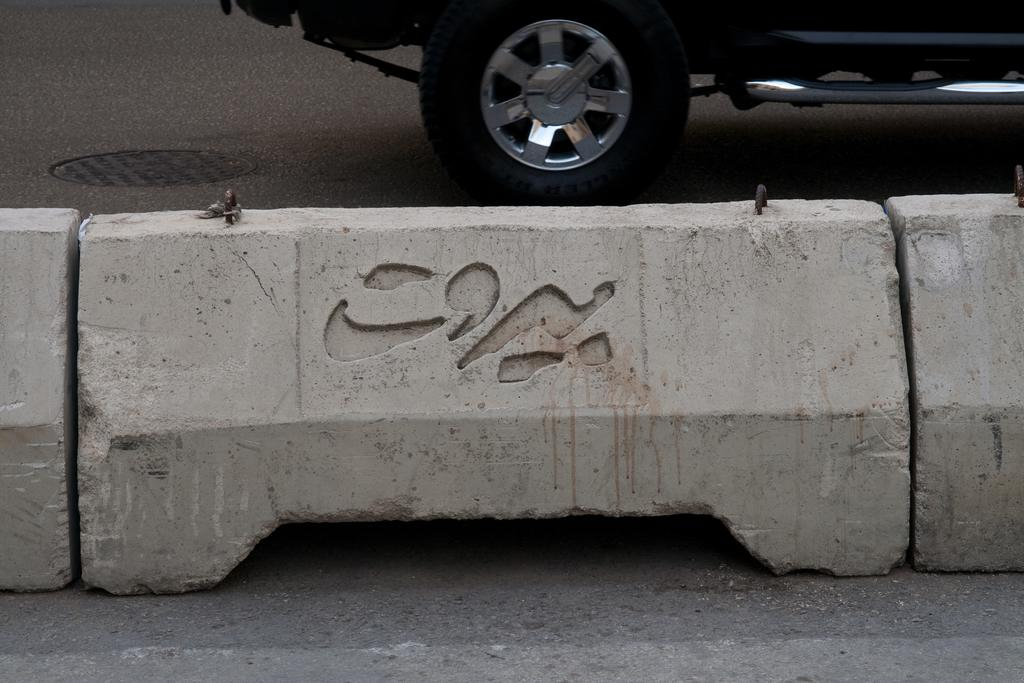What is the main feature of the image? There is a road in the image. Are there any distinguishing features on the road? Yes, there is a divider on the road. What color is the divider? The divider is ash in color. What type of vehicle can be seen on the road? There is a black vehicle on the road. How many members are on the team that is playing on the bridge in the image? There is no team or bridge present in the image; it features a road with a divider and a black vehicle. What type of mint is growing on the side of the road in the image? There is no mint plant visible in the image; it only shows a road, a divider, and a black vehicle. 